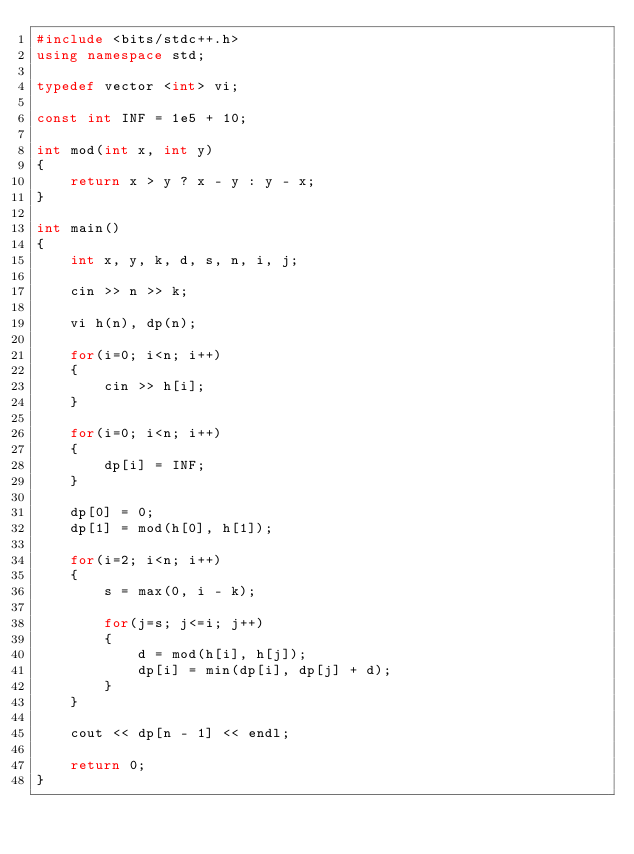Convert code to text. <code><loc_0><loc_0><loc_500><loc_500><_C++_>#include <bits/stdc++.h>
using namespace std; 

typedef vector <int> vi; 

const int INF = 1e5 + 10; 

int mod(int x, int y)
{
	return x > y ? x - y : y - x; 
}

int main()
{
	int x, y, k, d, s, n, i, j; 

	cin >> n >> k; 

	vi h(n), dp(n); 

	for(i=0; i<n; i++)
	{
		cin >> h[i]; 
	}

	for(i=0; i<n; i++)
	{
		dp[i] = INF; 
	}

	dp[0] = 0;  
	dp[1] = mod(h[0], h[1]); 

	for(i=2; i<n; i++)
	{
		s = max(0, i - k); 

		for(j=s; j<=i; j++)
		{
			d = mod(h[i], h[j]); 
			dp[i] = min(dp[i], dp[j] + d); 
		}
    }
  
	cout << dp[n - 1] << endl; 

	return 0; 
}</code> 